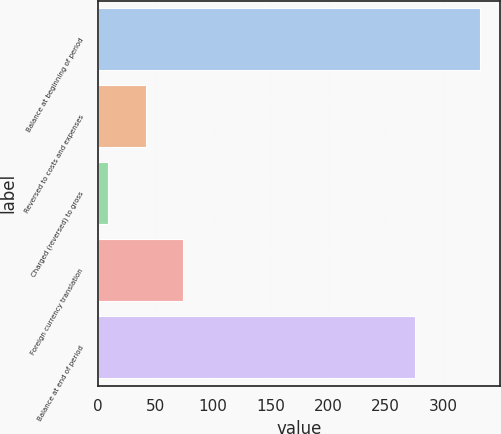Convert chart. <chart><loc_0><loc_0><loc_500><loc_500><bar_chart><fcel>Balance at beginning of period<fcel>Reversed to costs and expenses<fcel>Charged (reversed) to gross<fcel>Foreign currency translation<fcel>Balance at end of period<nl><fcel>332.2<fcel>41.5<fcel>9.2<fcel>73.8<fcel>275.1<nl></chart> 